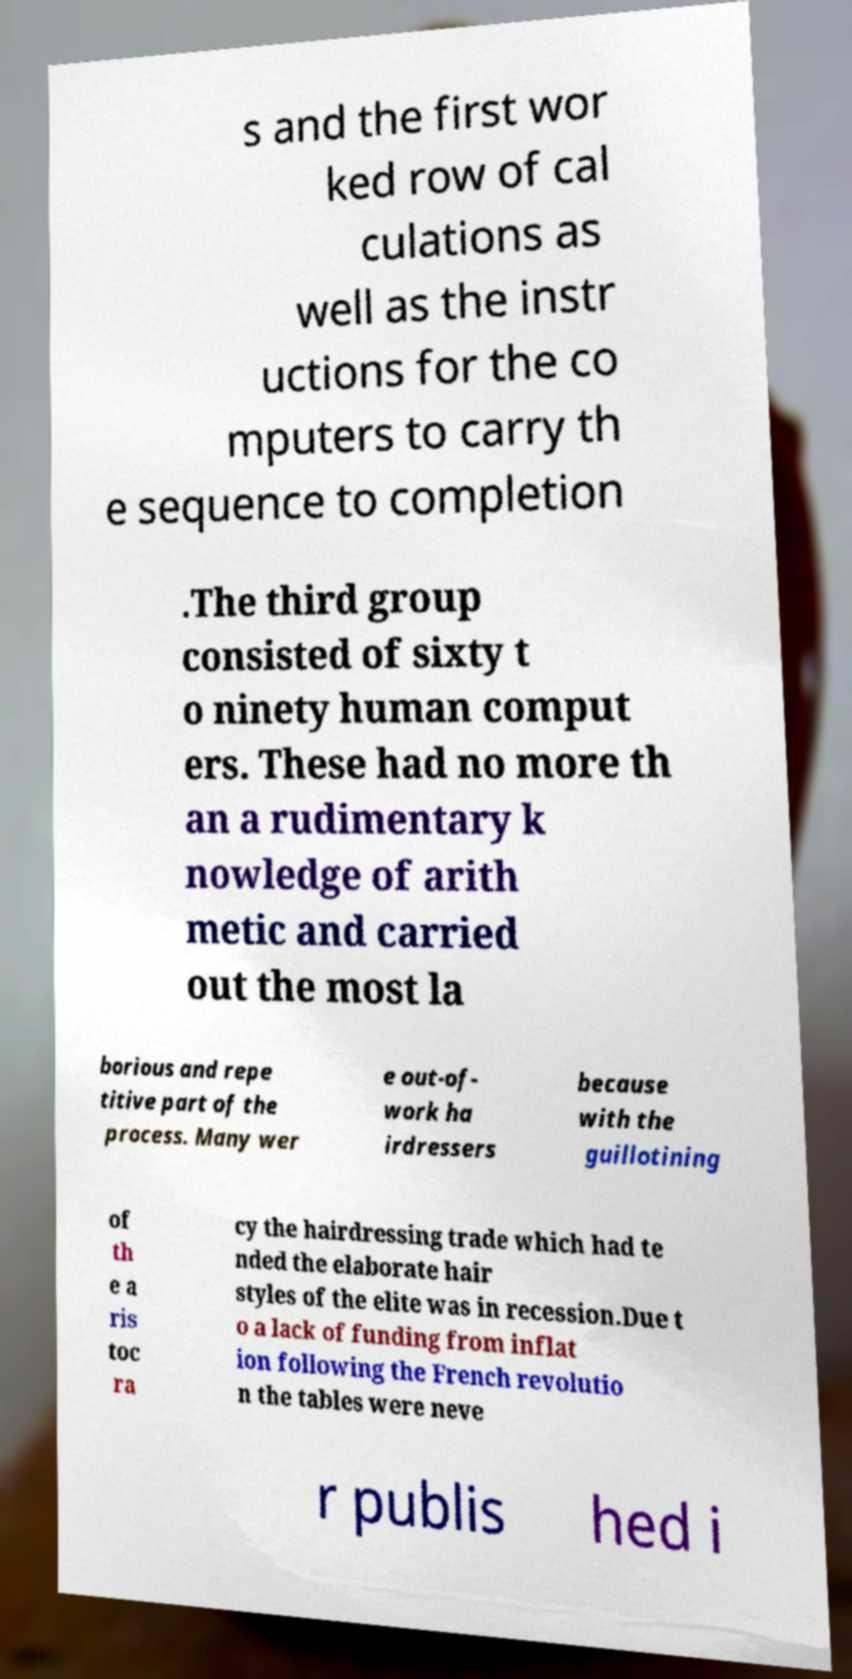Please identify and transcribe the text found in this image. s and the first wor ked row of cal culations as well as the instr uctions for the co mputers to carry th e sequence to completion .The third group consisted of sixty t o ninety human comput ers. These had no more th an a rudimentary k nowledge of arith metic and carried out the most la borious and repe titive part of the process. Many wer e out-of- work ha irdressers because with the guillotining of th e a ris toc ra cy the hairdressing trade which had te nded the elaborate hair styles of the elite was in recession.Due t o a lack of funding from inflat ion following the French revolutio n the tables were neve r publis hed i 